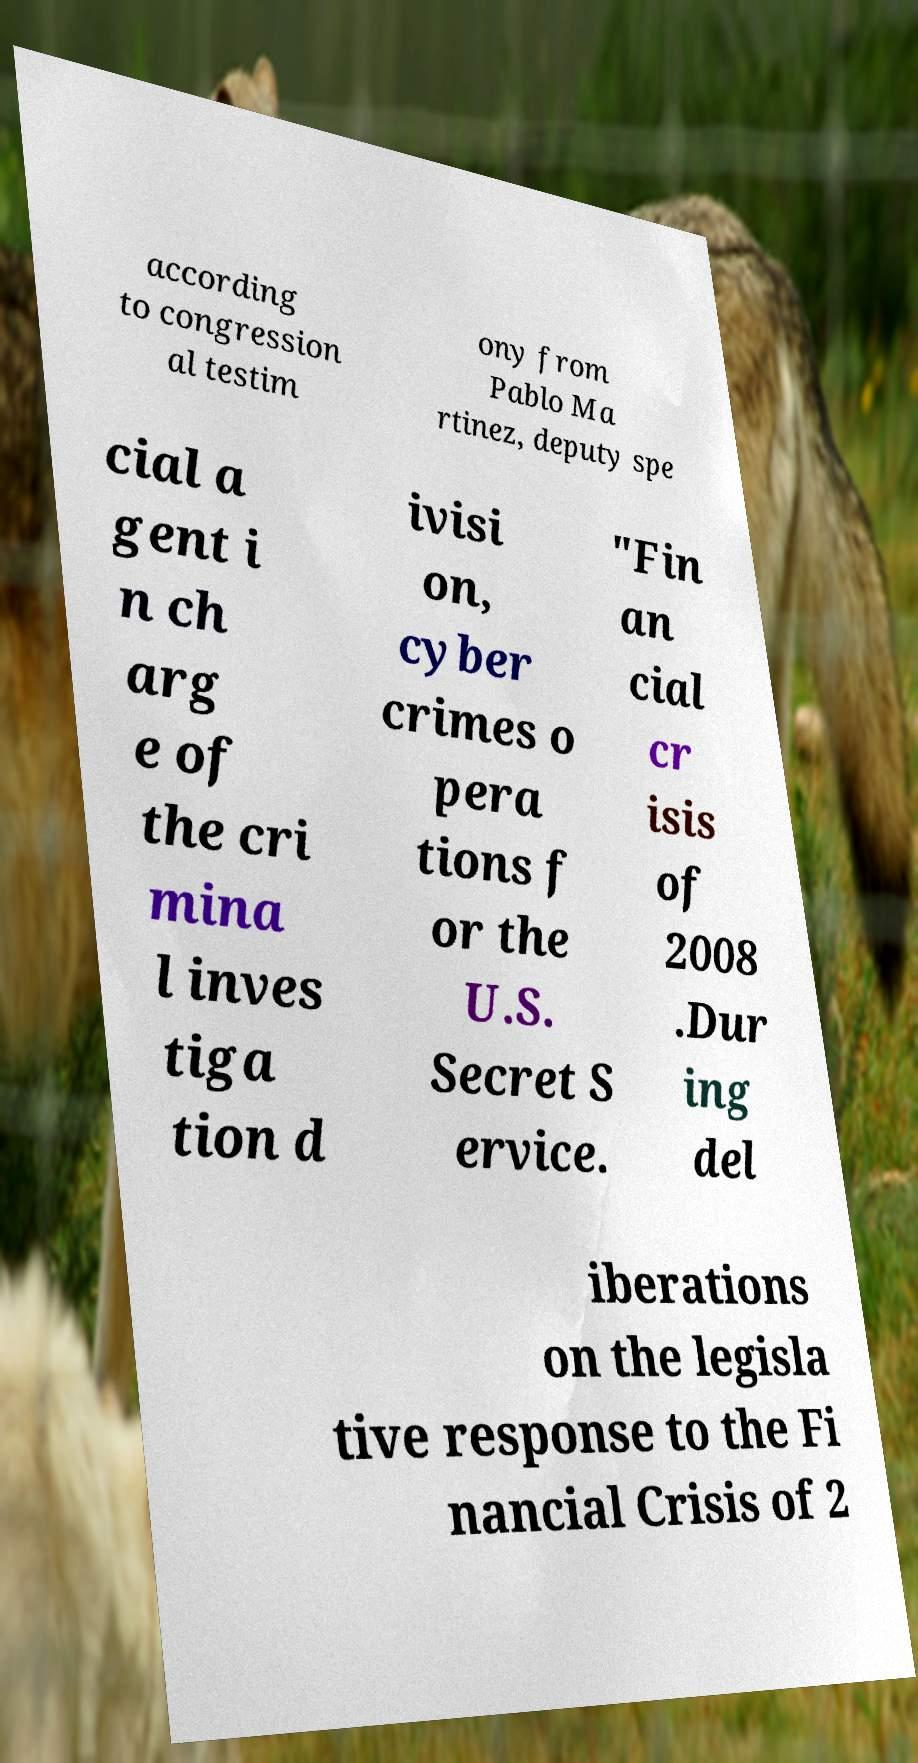There's text embedded in this image that I need extracted. Can you transcribe it verbatim? according to congression al testim ony from Pablo Ma rtinez, deputy spe cial a gent i n ch arg e of the cri mina l inves tiga tion d ivisi on, cyber crimes o pera tions f or the U.S. Secret S ervice. "Fin an cial cr isis of 2008 .Dur ing del iberations on the legisla tive response to the Fi nancial Crisis of 2 